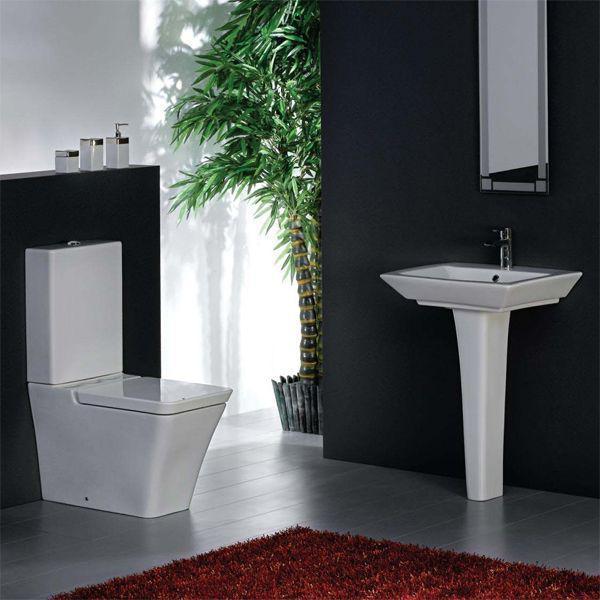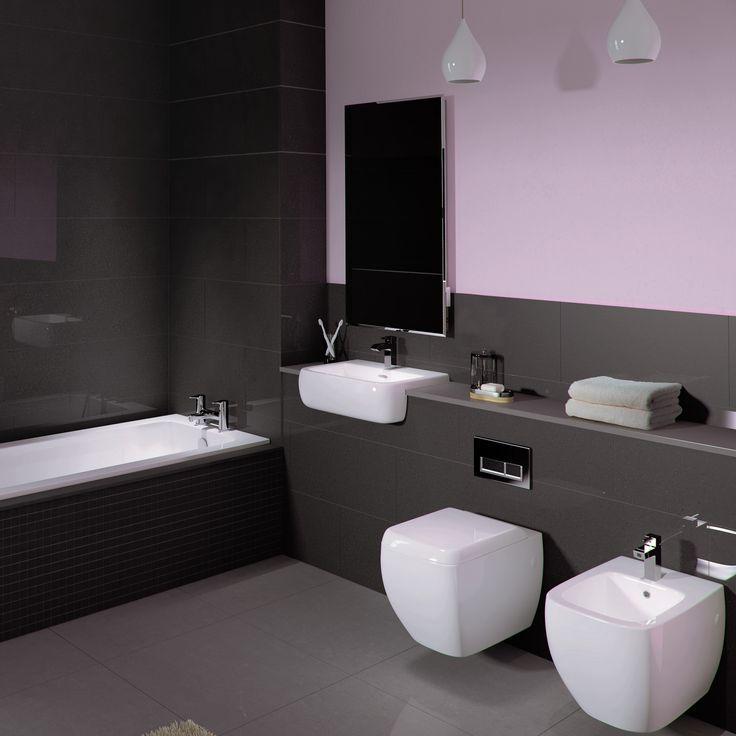The first image is the image on the left, the second image is the image on the right. For the images shown, is this caption "A bathroom features a toilet to the right of the sink." true? Answer yes or no. No. The first image is the image on the left, the second image is the image on the right. Assess this claim about the two images: "There is a rectangular toilet in one of the images.". Correct or not? Answer yes or no. Yes. 